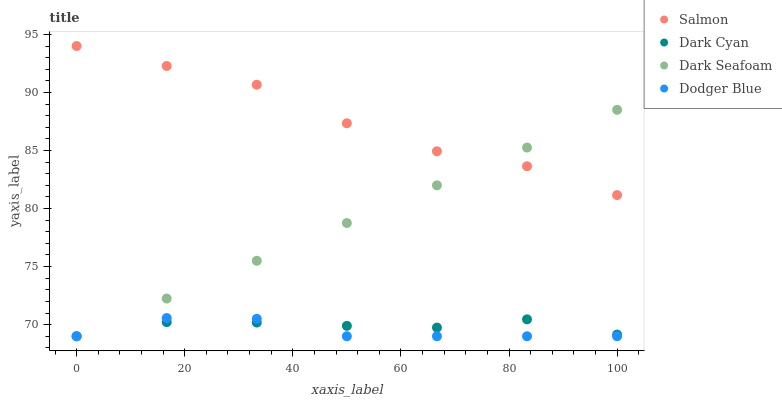Does Dodger Blue have the minimum area under the curve?
Answer yes or no. Yes. Does Salmon have the maximum area under the curve?
Answer yes or no. Yes. Does Dark Seafoam have the minimum area under the curve?
Answer yes or no. No. Does Dark Seafoam have the maximum area under the curve?
Answer yes or no. No. Is Dark Seafoam the smoothest?
Answer yes or no. Yes. Is Salmon the roughest?
Answer yes or no. Yes. Is Dodger Blue the smoothest?
Answer yes or no. No. Is Dodger Blue the roughest?
Answer yes or no. No. Does Dark Cyan have the lowest value?
Answer yes or no. Yes. Does Salmon have the lowest value?
Answer yes or no. No. Does Salmon have the highest value?
Answer yes or no. Yes. Does Dodger Blue have the highest value?
Answer yes or no. No. Is Dark Cyan less than Salmon?
Answer yes or no. Yes. Is Salmon greater than Dark Cyan?
Answer yes or no. Yes. Does Dark Cyan intersect Dodger Blue?
Answer yes or no. Yes. Is Dark Cyan less than Dodger Blue?
Answer yes or no. No. Is Dark Cyan greater than Dodger Blue?
Answer yes or no. No. Does Dark Cyan intersect Salmon?
Answer yes or no. No. 